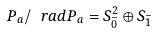Convert formula to latex. <formula><loc_0><loc_0><loc_500><loc_500>P _ { a } / \ r a d P _ { a } = S _ { \bar { 0 } } ^ { 2 } \oplus S _ { \bar { 1 } }</formula> 